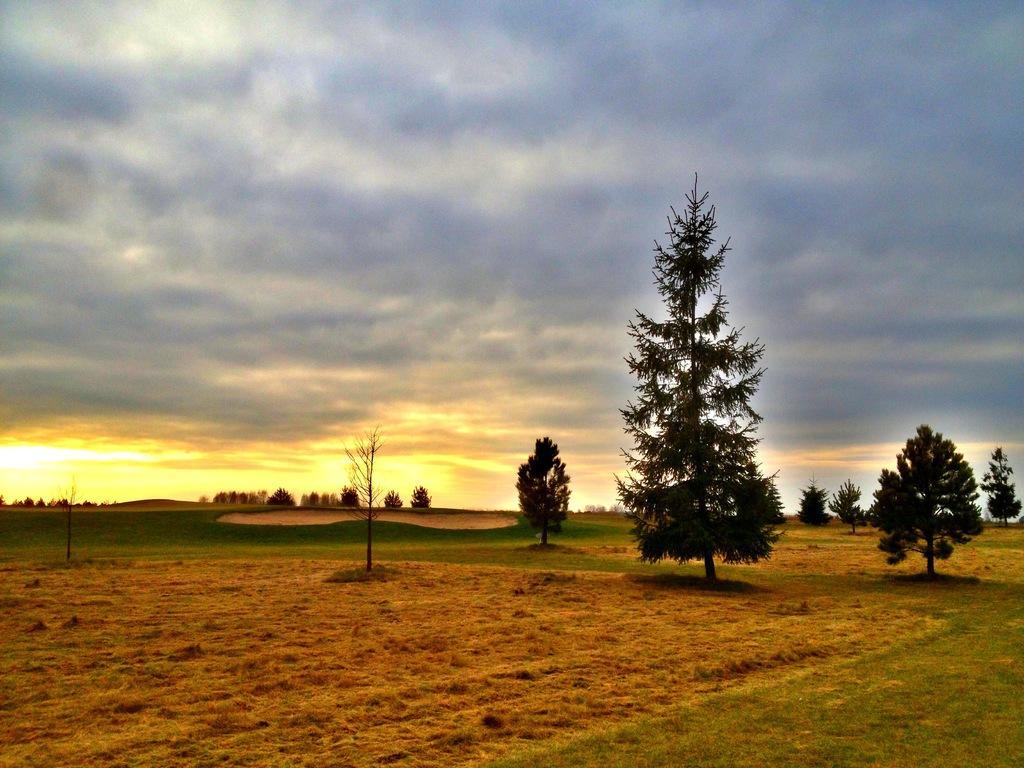Describe this image in one or two sentences. In this image there are few plants, grass, sunrise and some clouds in the sky. 